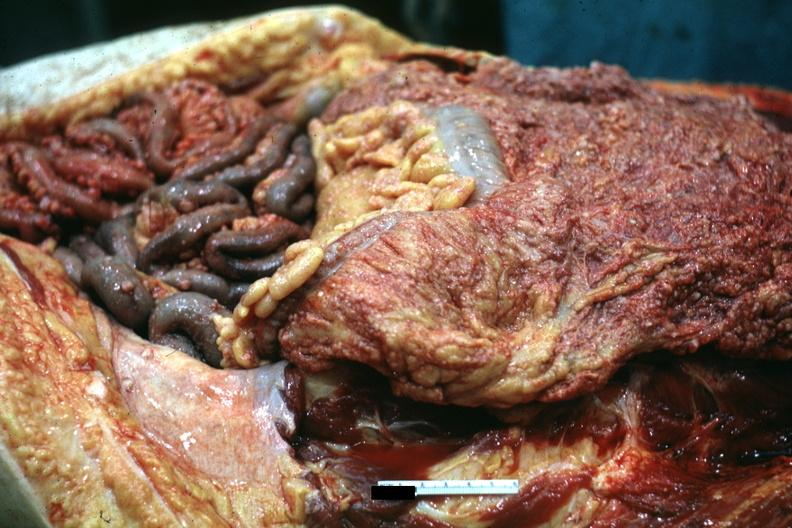what is present?
Answer the question using a single word or phrase. Carcinomatosis 